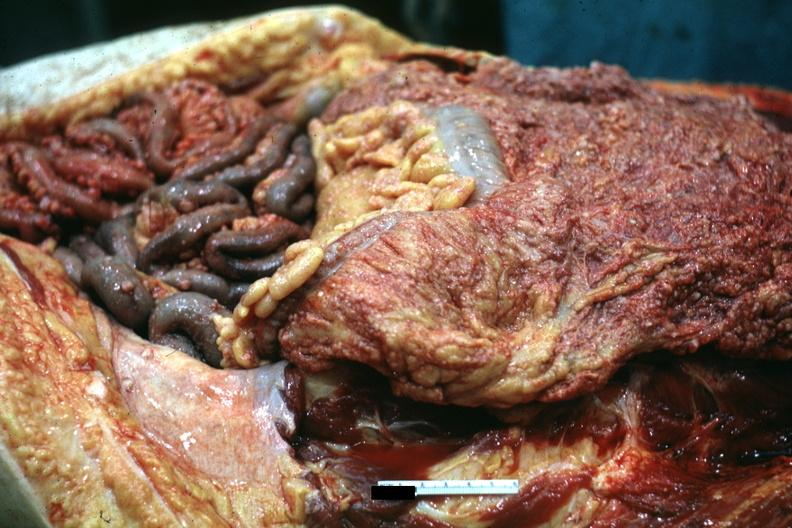what is present?
Answer the question using a single word or phrase. Carcinomatosis 